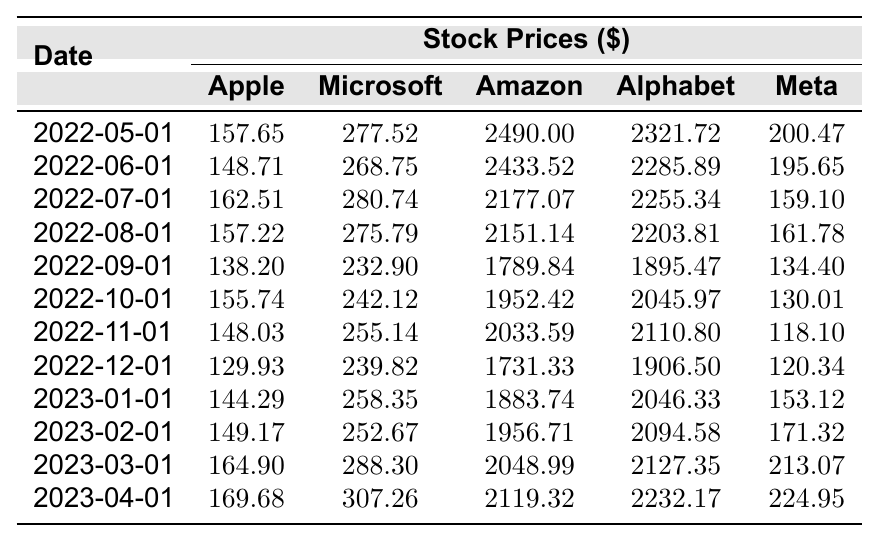What was the stock price of Microsoft on March 1, 2023? Referring to the row for March 1, 2023, the price listed for Microsoft is 288.30.
Answer: 288.30 Which company had the highest stock price on April 1, 2023? Looking at the row for April 1, 2023, Alphabet has the highest price at 2232.17 compared to the other companies.
Answer: Alphabet What is the difference in stock price for Apple from May 1, 2022, to April 1, 2023? Apple's price on May 1, 2022, is 157.65, and on April 1, 2023, it is 169.68. The difference is 169.68 - 157.65 = 12.03.
Answer: 12.03 What is the average stock price of Amazon over the provided period? First, sum the Amazon prices: (2490.00 + 2433.52 + 2177.07 + 2151.14 + 1789.84 + 1952.42 + 2033.59 + 1731.33 + 1883.74 + 1956.71 + 2048.99 + 2119.32) = 22553.09. There are 12 months, so the average is 22553.09 / 12 = 1879.42.
Answer: 1879.42 Did Meta's stock price ever drop below 130 during the year? Checking the prices for Meta, the lowest value is 118.10 on November 1, 2022, which is below 130.
Answer: Yes Which tech company showed the most significant price increase from October 1, 2022, to April 1, 2023? Calculate the price change: Apple (155.74 to 169.68): 169.68 - 155.74 = 13.94, Microsoft (242.12 to 307.26): 307.26 - 242.12 = 65.14, Amazon (1952.42 to 2119.32): 2119.32 - 1952.42 = 166.90, Alphabet (2045.97 to 2232.17): 2232.17 - 2045.97 = 186.20, Meta (130.01 to 224.95): 224.95 - 130.01 = 94.94. Alphabet had the highest increase of 186.20.
Answer: Alphabet What was the trend of Apple's stock price over the past year? By reviewing the prices month by month, Apple's price fluctuated but generally increased from 157.65 in May 2022 to 169.68 in April 2023, indicating an upward trend overall.
Answer: Upward trend 